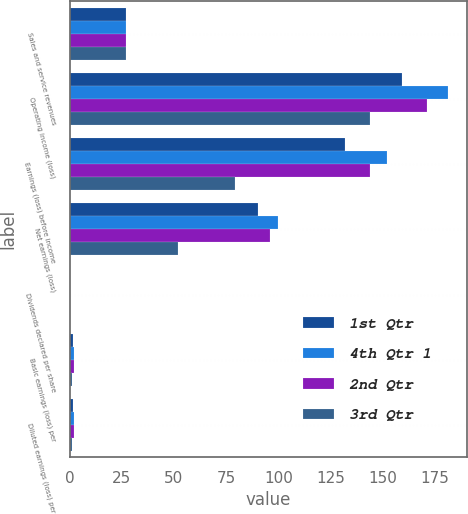<chart> <loc_0><loc_0><loc_500><loc_500><stacked_bar_chart><ecel><fcel>Sales and service revenues<fcel>Operating income (loss)<fcel>Earnings (loss) before income<fcel>Net earnings (loss)<fcel>Dividends declared per share<fcel>Basic earnings (loss) per<fcel>Diluted earnings (loss) per<nl><fcel>1st Qtr<fcel>27.025<fcel>159<fcel>132<fcel>90<fcel>0.2<fcel>1.83<fcel>1.81<nl><fcel>4th Qtr 1<fcel>27.025<fcel>181<fcel>152<fcel>100<fcel>0.2<fcel>2.05<fcel>2.04<nl><fcel>2nd Qtr<fcel>27.025<fcel>171<fcel>144<fcel>96<fcel>0.2<fcel>1.97<fcel>1.96<nl><fcel>3rd Qtr<fcel>27.025<fcel>144<fcel>79<fcel>52<fcel>0.4<fcel>1.07<fcel>1.05<nl></chart> 